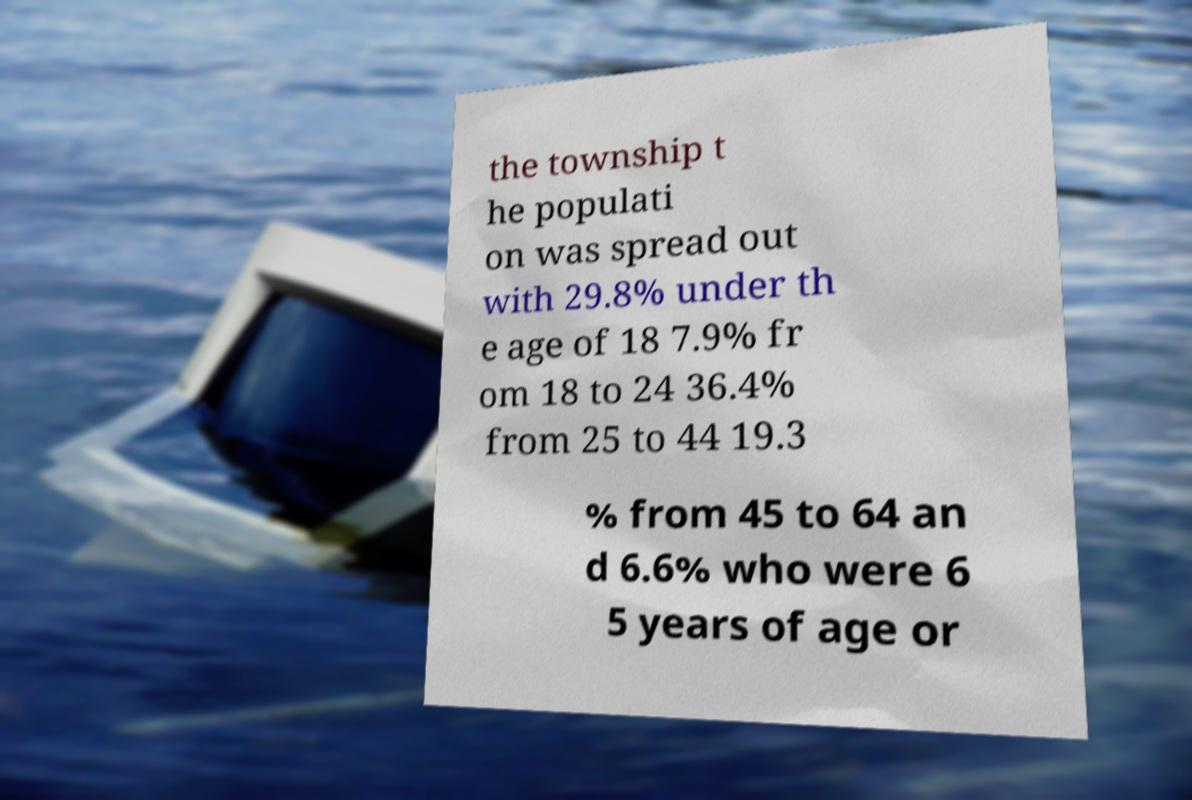Could you assist in decoding the text presented in this image and type it out clearly? the township t he populati on was spread out with 29.8% under th e age of 18 7.9% fr om 18 to 24 36.4% from 25 to 44 19.3 % from 45 to 64 an d 6.6% who were 6 5 years of age or 